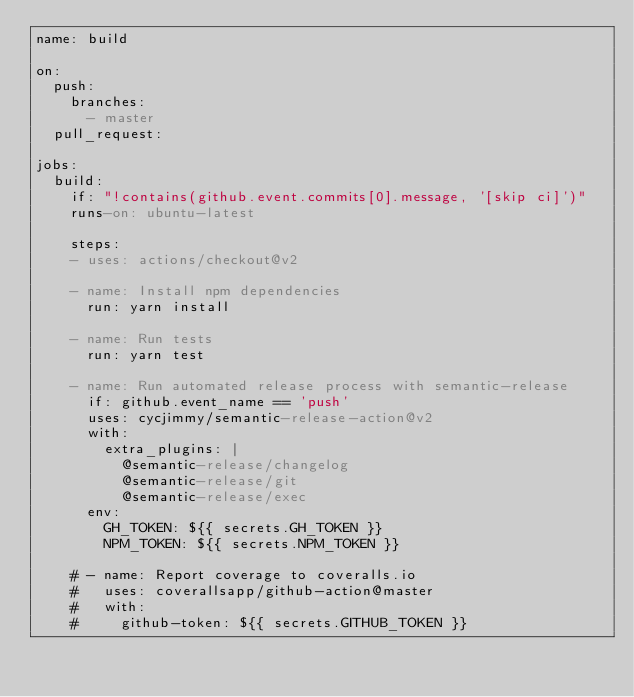Convert code to text. <code><loc_0><loc_0><loc_500><loc_500><_YAML_>name: build

on:
  push:
    branches:
      - master
  pull_request:

jobs:
  build:
    if: "!contains(github.event.commits[0].message, '[skip ci]')"
    runs-on: ubuntu-latest

    steps:
    - uses: actions/checkout@v2

    - name: Install npm dependencies
      run: yarn install

    - name: Run tests
      run: yarn test

    - name: Run automated release process with semantic-release
      if: github.event_name == 'push'
      uses: cycjimmy/semantic-release-action@v2
      with:
        extra_plugins: |
          @semantic-release/changelog
          @semantic-release/git
          @semantic-release/exec
      env:
        GH_TOKEN: ${{ secrets.GH_TOKEN }}
        NPM_TOKEN: ${{ secrets.NPM_TOKEN }}

    # - name: Report coverage to coveralls.io
    #   uses: coverallsapp/github-action@master
    #   with:
    #     github-token: ${{ secrets.GITHUB_TOKEN }}
</code> 